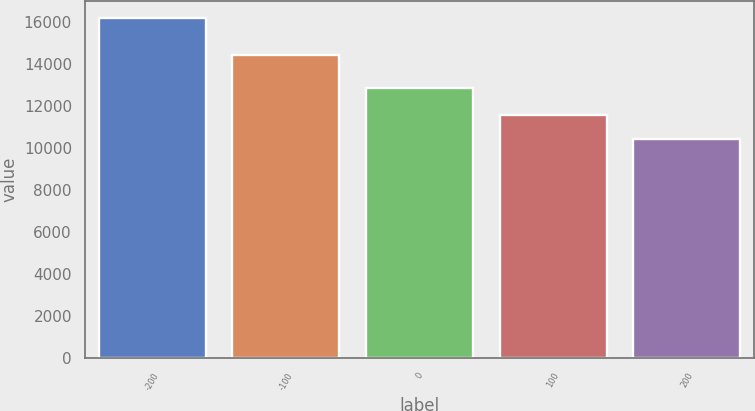Convert chart. <chart><loc_0><loc_0><loc_500><loc_500><bar_chart><fcel>-200<fcel>-100<fcel>0<fcel>100<fcel>200<nl><fcel>16205<fcel>14412<fcel>12879<fcel>11562<fcel>10423<nl></chart> 